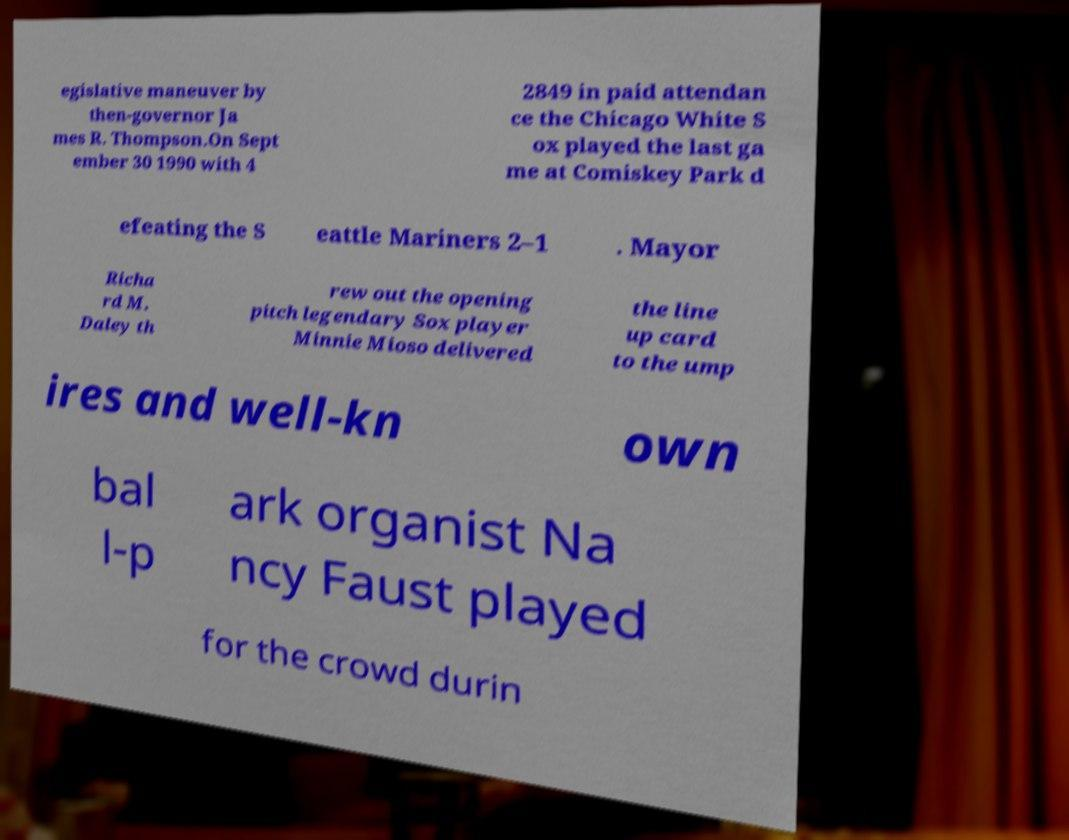What messages or text are displayed in this image? I need them in a readable, typed format. egislative maneuver by then-governor Ja mes R. Thompson.On Sept ember 30 1990 with 4 2849 in paid attendan ce the Chicago White S ox played the last ga me at Comiskey Park d efeating the S eattle Mariners 2–1 . Mayor Richa rd M. Daley th rew out the opening pitch legendary Sox player Minnie Mioso delivered the line up card to the ump ires and well-kn own bal l-p ark organist Na ncy Faust played for the crowd durin 